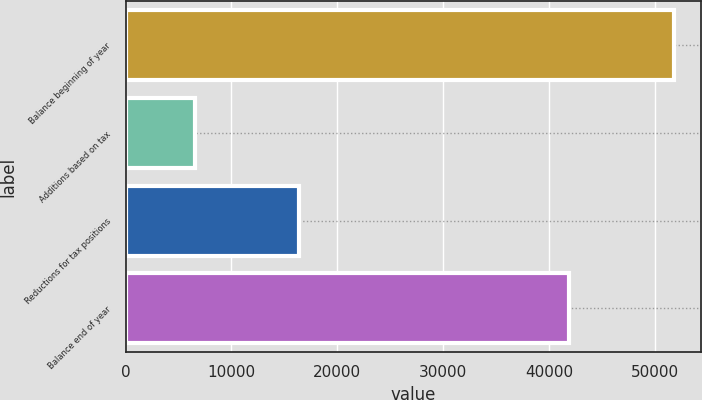Convert chart. <chart><loc_0><loc_0><loc_500><loc_500><bar_chart><fcel>Balance beginning of year<fcel>Additions based on tax<fcel>Reductions for tax positions<fcel>Balance end of year<nl><fcel>51770<fcel>6528<fcel>16375<fcel>41923<nl></chart> 